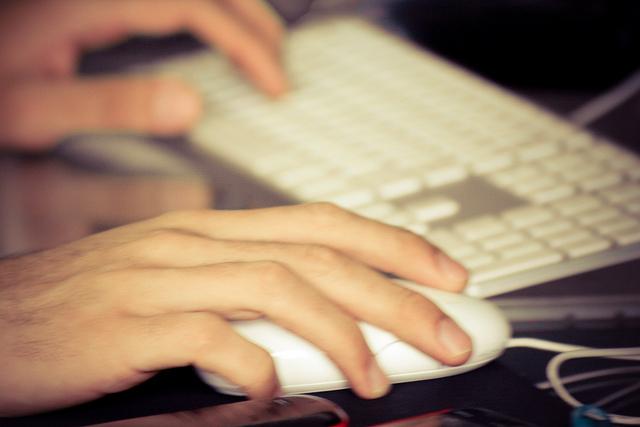Is the mouse wireless?
Concise answer only. No. Is the person typing fast?
Answer briefly. No. Is he using Apple or PC?
Answer briefly. Apple. Is this person left handed?
Give a very brief answer. No. 